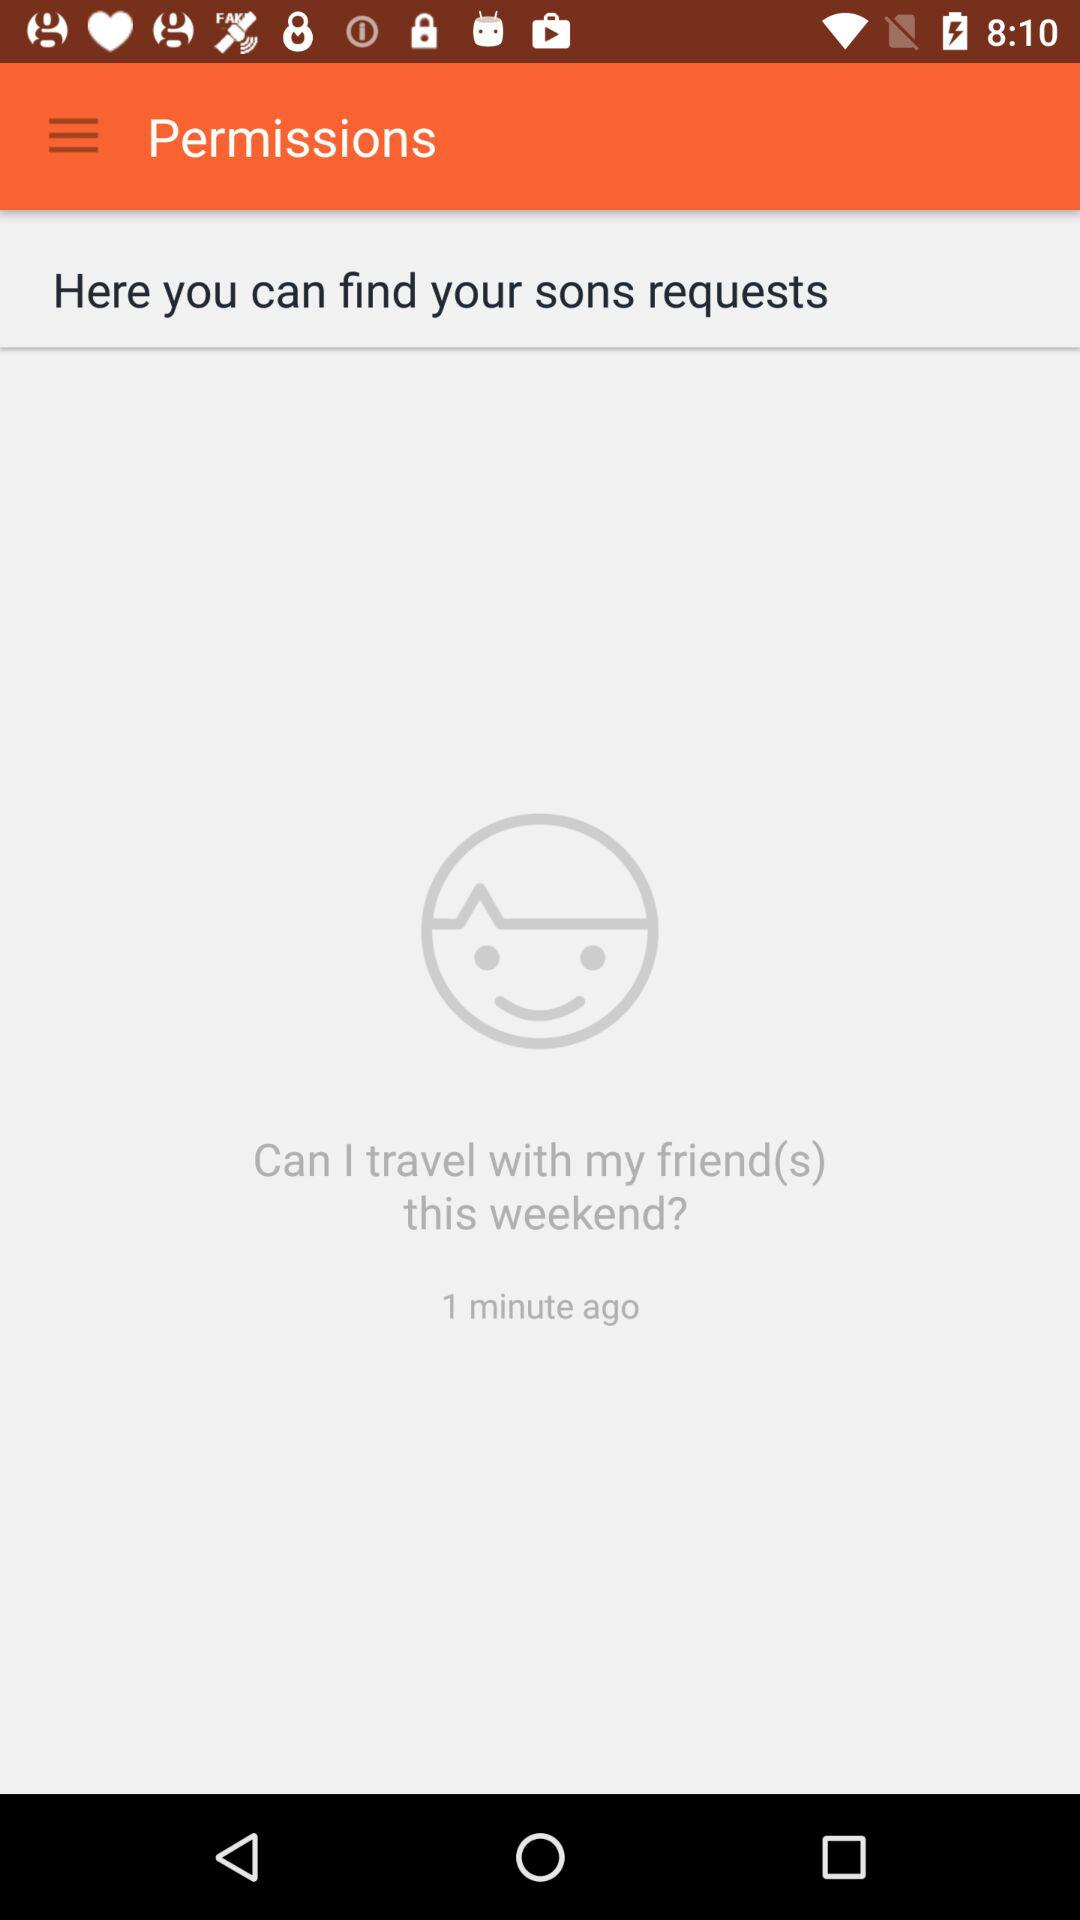How long ago was the request made?
Answer the question using a single word or phrase. 1 minute ago 